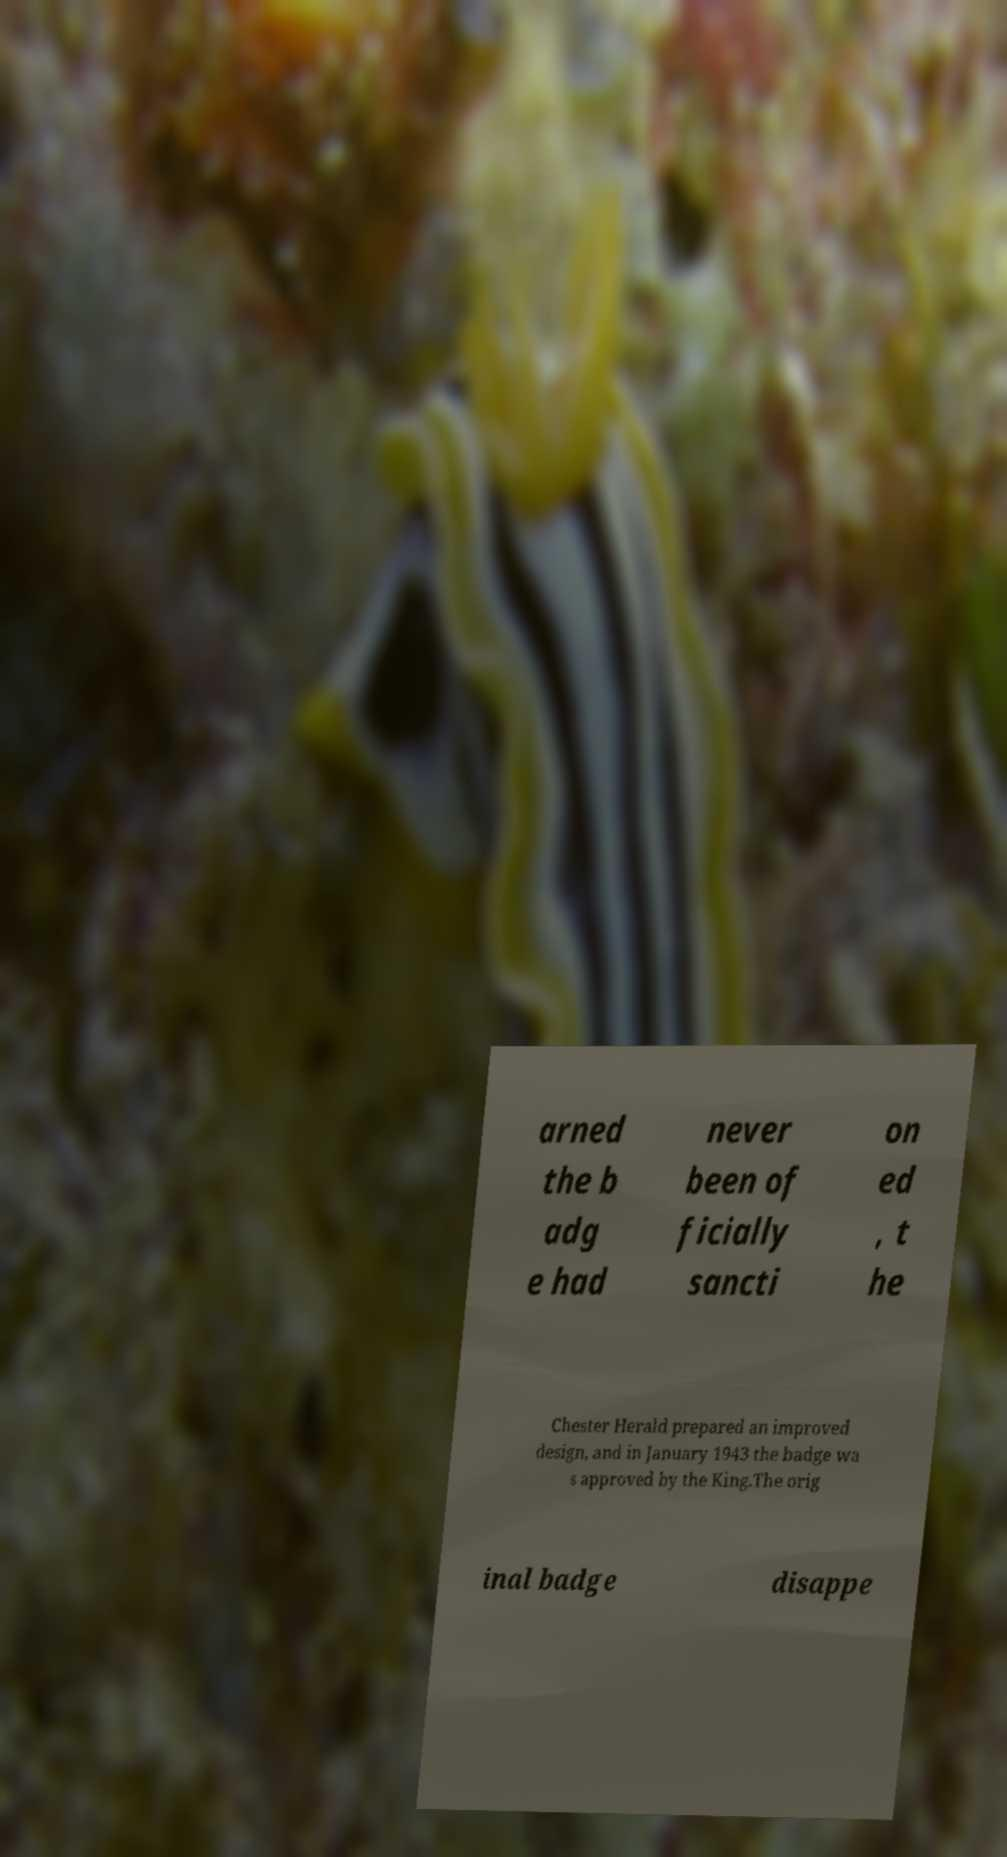What messages or text are displayed in this image? I need them in a readable, typed format. arned the b adg e had never been of ficially sancti on ed , t he Chester Herald prepared an improved design, and in January 1943 the badge wa s approved by the King.The orig inal badge disappe 